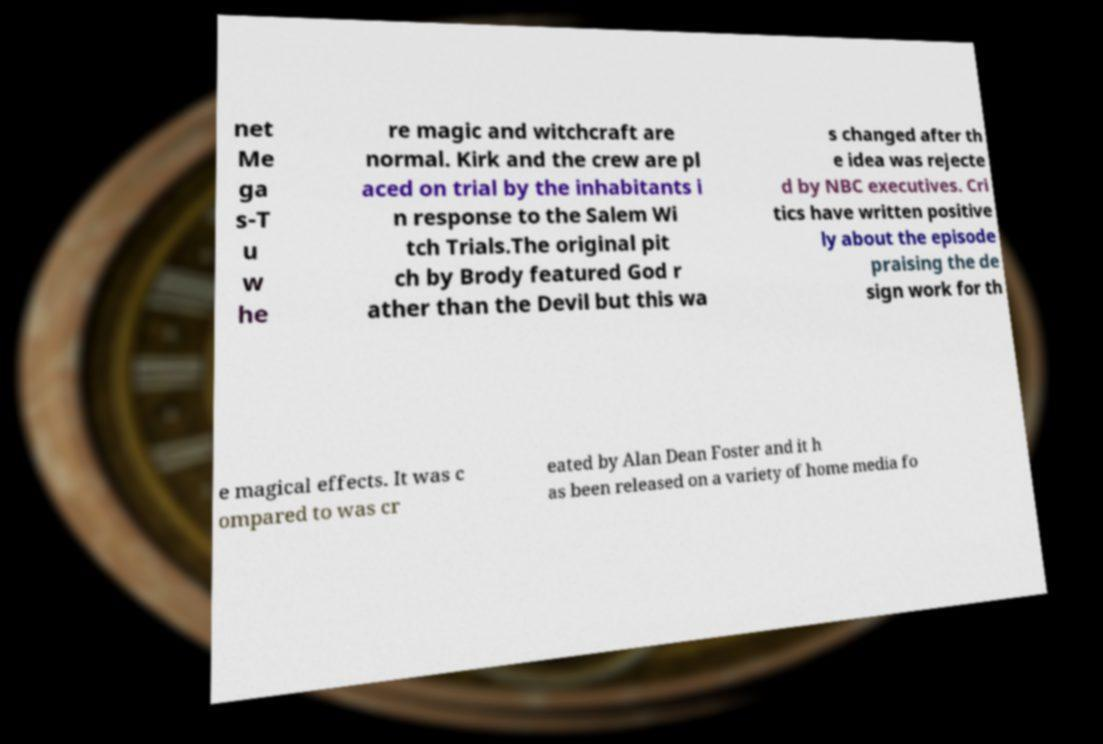For documentation purposes, I need the text within this image transcribed. Could you provide that? net Me ga s-T u w he re magic and witchcraft are normal. Kirk and the crew are pl aced on trial by the inhabitants i n response to the Salem Wi tch Trials.The original pit ch by Brody featured God r ather than the Devil but this wa s changed after th e idea was rejecte d by NBC executives. Cri tics have written positive ly about the episode praising the de sign work for th e magical effects. It was c ompared to was cr eated by Alan Dean Foster and it h as been released on a variety of home media fo 